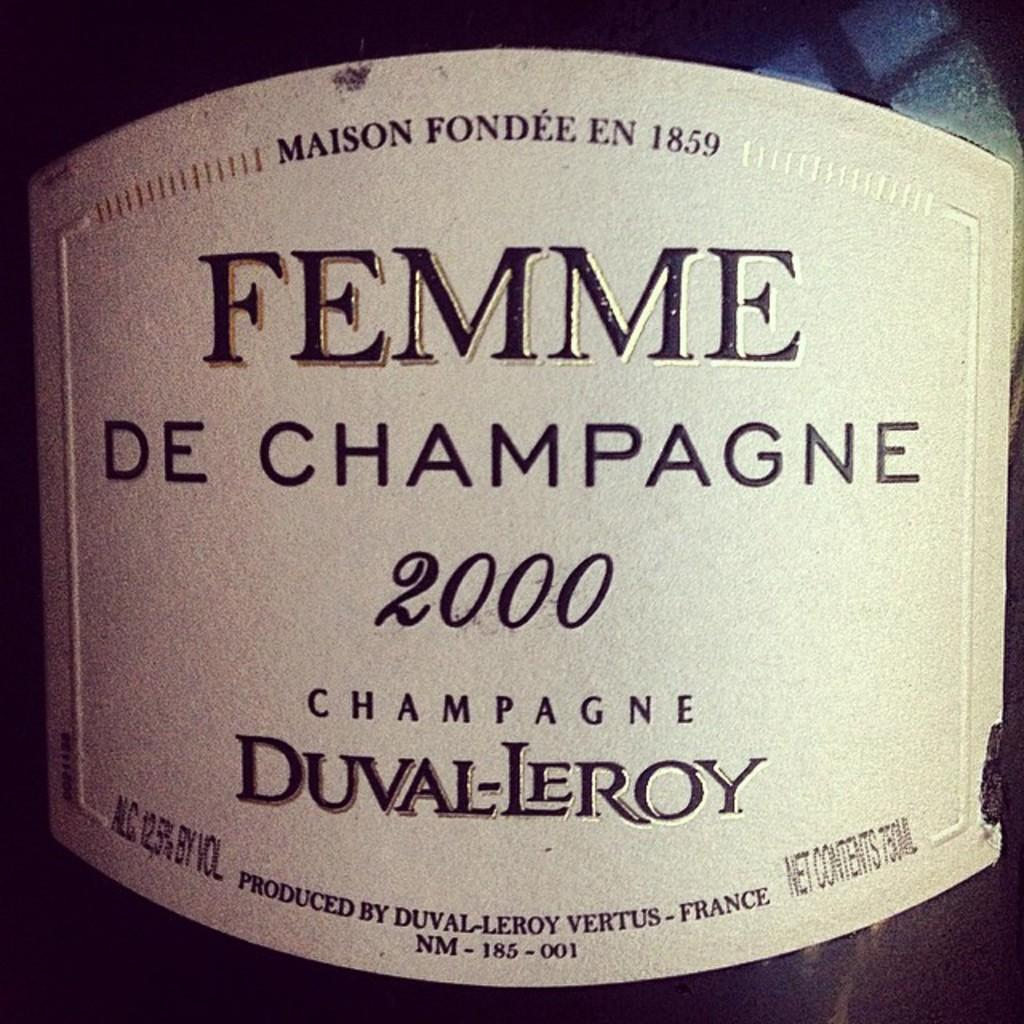<image>
Render a clear and concise summary of the photo. A Femme de Champagne label shows that it was bottled in 2000. 